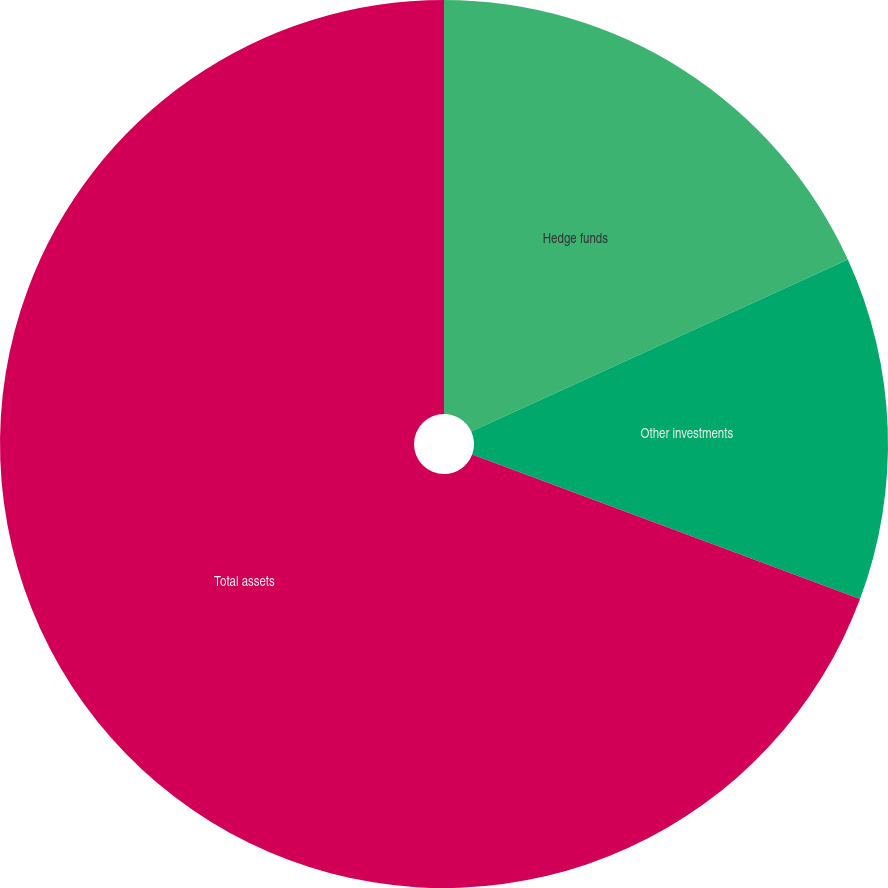Convert chart to OTSL. <chart><loc_0><loc_0><loc_500><loc_500><pie_chart><fcel>Hedge funds<fcel>Other investments<fcel>Total assets<nl><fcel>18.18%<fcel>12.5%<fcel>69.32%<nl></chart> 